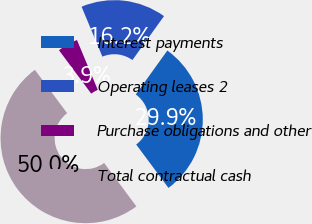Convert chart. <chart><loc_0><loc_0><loc_500><loc_500><pie_chart><fcel>Interest payments<fcel>Operating leases 2<fcel>Purchase obligations and other<fcel>Total contractual cash<nl><fcel>29.91%<fcel>16.21%<fcel>3.88%<fcel>50.0%<nl></chart> 